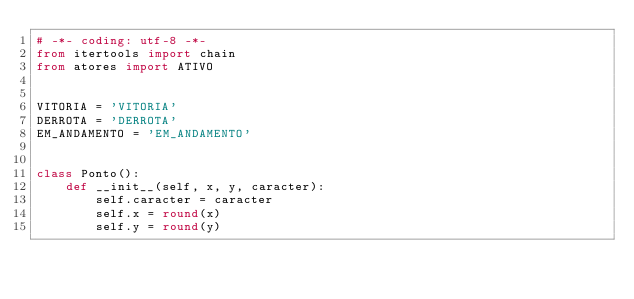Convert code to text. <code><loc_0><loc_0><loc_500><loc_500><_Python_># -*- coding: utf-8 -*-
from itertools import chain
from atores import ATIVO


VITORIA = 'VITORIA'
DERROTA = 'DERROTA'
EM_ANDAMENTO = 'EM_ANDAMENTO'


class Ponto():
    def __init__(self, x, y, caracter):
        self.caracter = caracter
        self.x = round(x)
        self.y = round(y)
</code> 